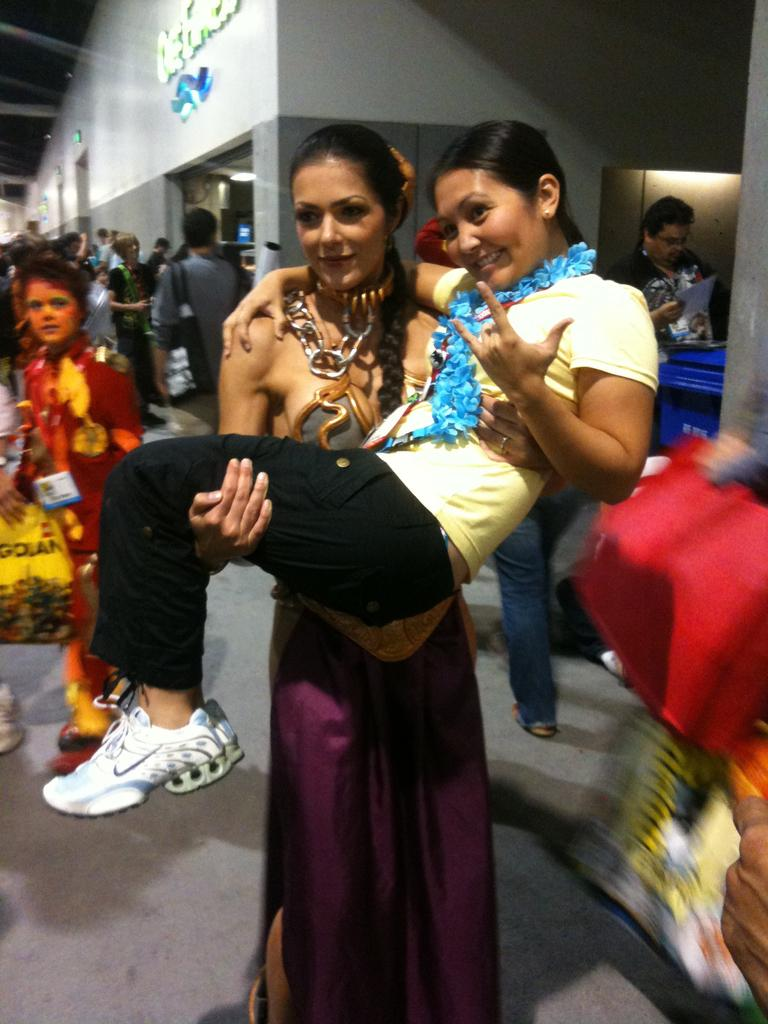What is happening between the two ladies in the image? There is a lady holding another lady in the image. What can be seen in the background of the image? There are many people and a building in the background of the image. What is the name of the building in the image? The building has a name on it, but the specific name is not mentioned in the provided facts. What can be observed about the lighting in the image? There are lights visible in the image. What type of seed can be seen growing on the lady's shoulder in the image? There is no seed visible on the lady's shoulder in the image. 